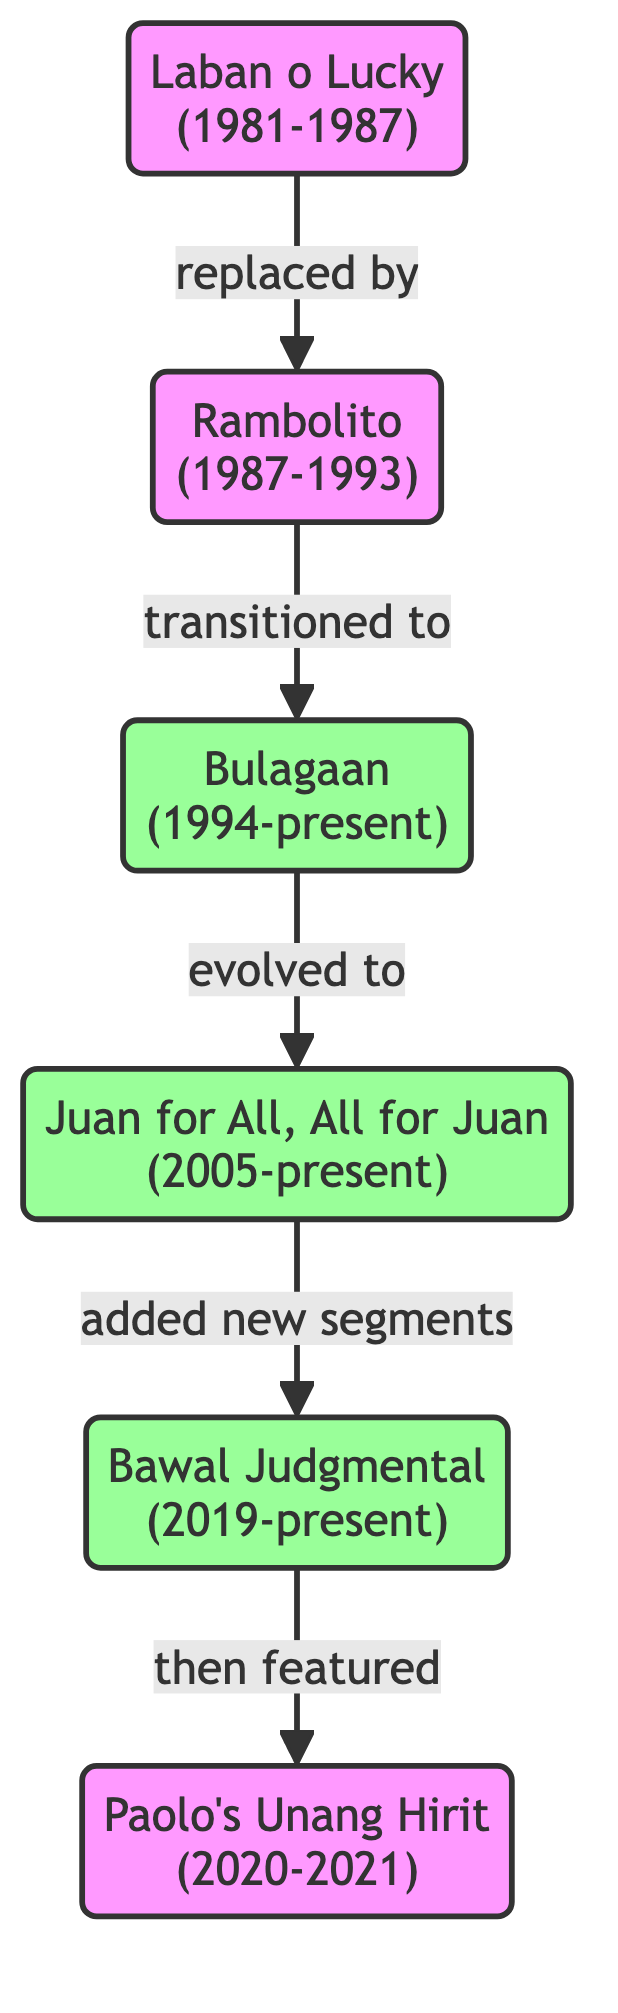What is the first game segment in the evolution? The diagram shows "Laban o Lucky" at the start, indicating it is the first game segment in the evolution.
Answer: Laban o Lucky Which segment replaced "Laban o Lucky"? The directed edge labeled "replaced by" leads from "Laban o Lucky" to "Rambolito", indicating that "Rambolito" is the segment that replaced it.
Answer: Rambolito How many segments are shown in the diagram? By counting each of the nodes in the diagram, there are a total of 6 game segments represented.
Answer: 6 Which segment is currently active and evolved from "Bulagaan"? The diagram indicates that "Juan for All, All for Juan" evolved from "Bulagaan", and it is currently active as stated in its label.
Answer: Juan for All, All for Juan What transition occurred from "Juan for All, All for Juan"? From the diagram, "Juan for All, All for Juan" added new segments which refers to "Bawal Judgmental".
Answer: added new segments In which years was "Paolo's Unang Hirit" active? Looking at the node details, "Paolo's Unang Hirit" is labeled with the years 2020-2021.
Answer: 2020-2021 What type of segment is "Bawal Judgmental"? Analyzing the description, "Bawal Judgmental" is a segment requiring contestants to guess correct individuals based on clues, categorizing it as a guessing game.
Answer: guessing game After which segment did "Paolo's Unang Hirit" feature? The directed edge from "Bawal Judgmental" to "Paolo's Unang Hirit" indicates that "Paolo's Unang Hirit" featured after "Bawal Judgmental".
Answer: Bawal Judgmental Which game segments are currently active? The currently active segments are indicated by the label style in the diagram, which highlights "Bulagaan", "Juan for All, All for Juan", and "Bawal Judgmental".
Answer: Bulagaan, Juan for All, All for Juan, Bawal Judgmental 